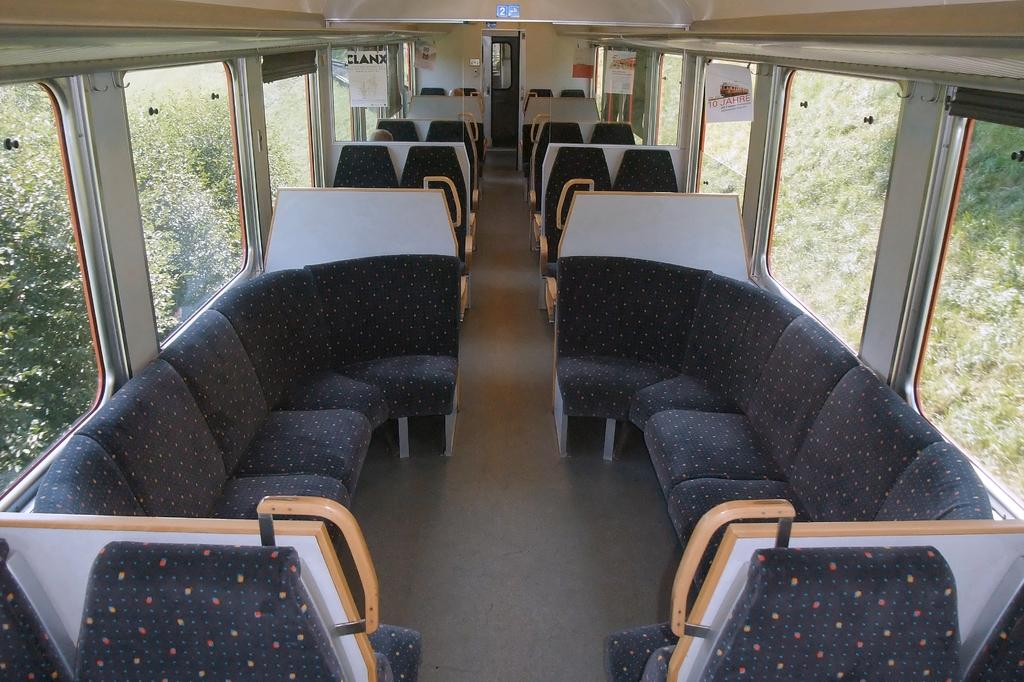What is the setting of the image? The image shows the inside of a vehicle. What can be seen outside the vehicle in the image? There are trees visible in the background of the image. How many pigs are sitting on the cup playing music in the image? There are no pigs, cups, or music present in the image; it shows the inside of a vehicle with trees visible in the background. 